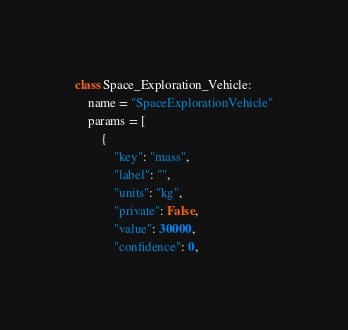<code> <loc_0><loc_0><loc_500><loc_500><_Python_>class Space_Exploration_Vehicle:
    name = "SpaceExplorationVehicle"
    params = [
        {
            "key": "mass",
            "label": "",
            "units": "kg",
            "private": False,
            "value": 30000,
            "confidence": 0,</code> 